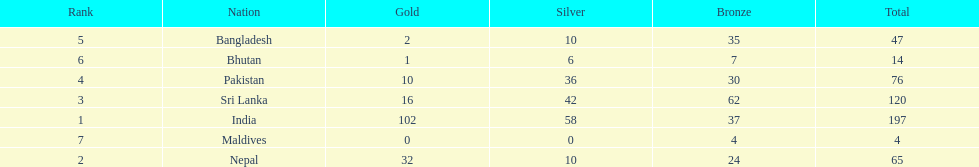Name the first country on the table? India. 